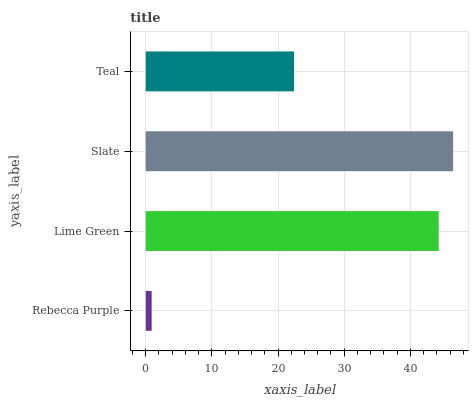Is Rebecca Purple the minimum?
Answer yes or no. Yes. Is Slate the maximum?
Answer yes or no. Yes. Is Lime Green the minimum?
Answer yes or no. No. Is Lime Green the maximum?
Answer yes or no. No. Is Lime Green greater than Rebecca Purple?
Answer yes or no. Yes. Is Rebecca Purple less than Lime Green?
Answer yes or no. Yes. Is Rebecca Purple greater than Lime Green?
Answer yes or no. No. Is Lime Green less than Rebecca Purple?
Answer yes or no. No. Is Lime Green the high median?
Answer yes or no. Yes. Is Teal the low median?
Answer yes or no. Yes. Is Teal the high median?
Answer yes or no. No. Is Slate the low median?
Answer yes or no. No. 